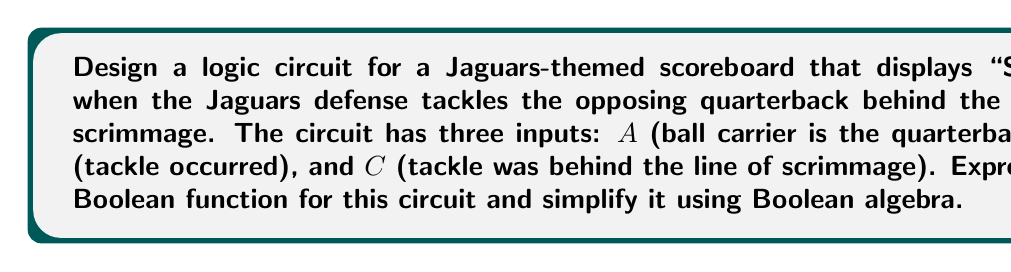Give your solution to this math problem. Let's approach this step-by-step:

1) First, we need to determine when "SACK" should be displayed. This occurs when all three conditions are true:
   - A: The ball carrier is the quarterback
   - B: A tackle occurred
   - C: The tackle was behind the line of scrimmage

2) We can express this as a Boolean function:
   $$F = A \cdot B \cdot C$$

3) This function is already in its simplest form, as all three inputs must be true for the output to be true. However, let's verify this using Boolean algebra laws:

4) Using the associative law: $$(A \cdot B) \cdot C = A \cdot (B \cdot C)$$

5) Using the commutative law, we can rearrange the terms in any order:
   $$A \cdot B \cdot C = B \cdot A \cdot C = C \cdot A \cdot B$$

6) We can't apply the distributive law or absorption law to simplify further, as there are no terms to distribute or absorb.

7) Therefore, the simplified Boolean function remains:
   $$F = A \cdot B \cdot C$$

8) This can be implemented with a single AND gate with three inputs.

[asy]
unitsize(1cm);
pair A = (0,2), B = (0,1), C = (0,0);
pair AND = (2,1);
pair OUT = (4,1);

draw(A--AND);
draw(B--AND);
draw(C--AND);
draw(AND--OUT);

label("A", A, W);
label("B", B, W);
label("C", C, W);
label("F", OUT, E);

path p = (1.5,0.5)--(2.5,0.5)--arc((2,1),0.5,270,90)--(1.5,1.5)--cycle;
fill(p);
draw(p);
Answer: $$F = A \cdot B \cdot C$$ 